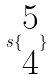<formula> <loc_0><loc_0><loc_500><loc_500>s \{ \begin{matrix} 5 \\ 4 \end{matrix} \}</formula> 